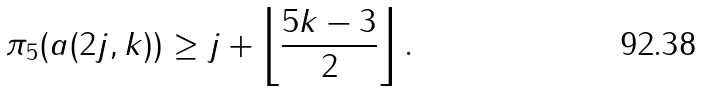Convert formula to latex. <formula><loc_0><loc_0><loc_500><loc_500>\pi _ { 5 } ( a ( 2 j , k ) ) \geq j + \left \lfloor \frac { 5 k - 3 } { 2 } \right \rfloor .</formula> 